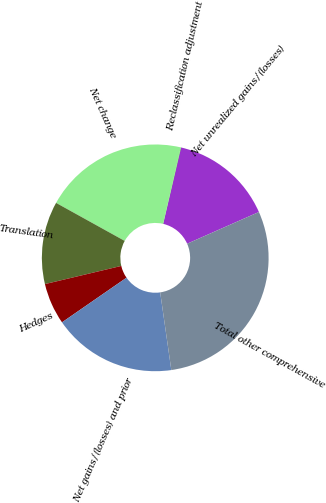Convert chart. <chart><loc_0><loc_0><loc_500><loc_500><pie_chart><fcel>Net unrealized gains/(losses)<fcel>Reclassification adjustment<fcel>Net change<fcel>Translation<fcel>Hedges<fcel>Net gains/(losses) and prior<fcel>Total other comprehensive<nl><fcel>14.7%<fcel>0.05%<fcel>20.56%<fcel>11.77%<fcel>5.91%<fcel>17.63%<fcel>29.35%<nl></chart> 